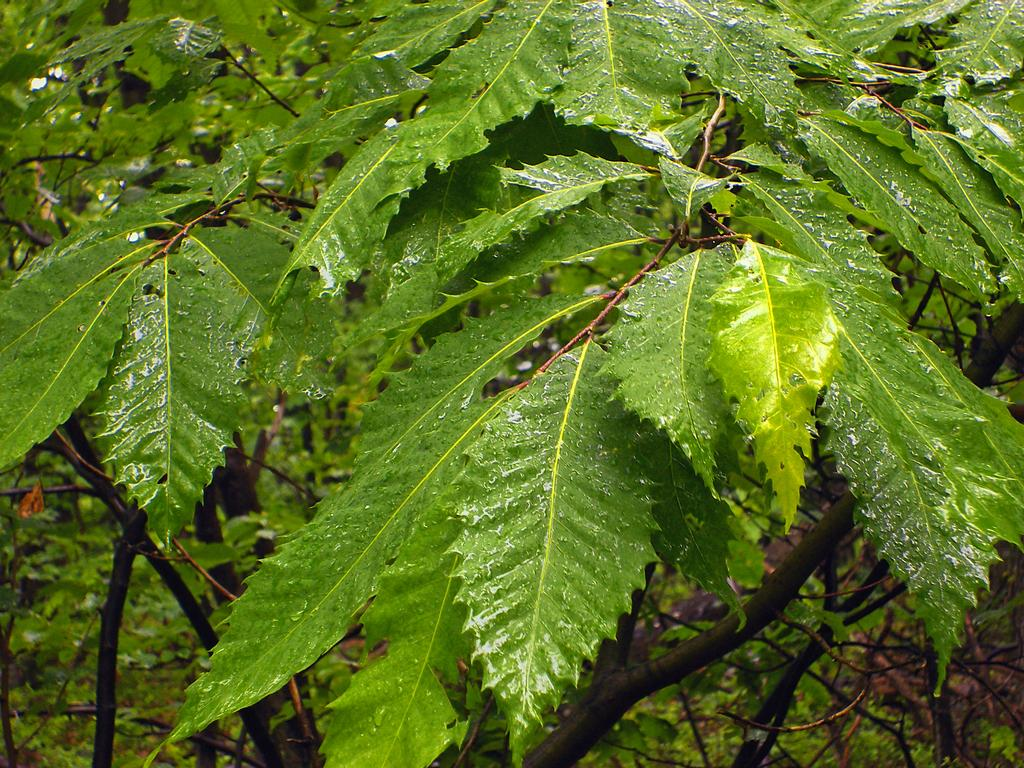What type of vegetation is present in the image? There are leaves in the image. To which part of a plant do these leaves belong? The leaves belong to a branch. What is the condition of the leaves in the image? There are water droplets on the leaves. What route does the cause take to reach the suggestion in the image? There is no cause, suggestion, or route present in the image; it only features leaves with water droplets on them. 